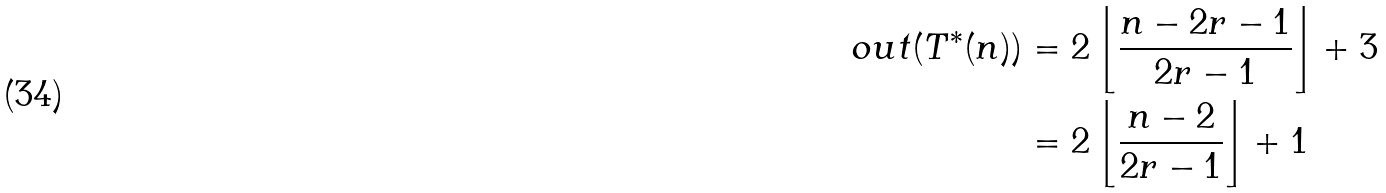Convert formula to latex. <formula><loc_0><loc_0><loc_500><loc_500>o u t ( T ^ { * } ( n ) ) & = 2 \left \lfloor \frac { n - 2 r - 1 } { 2 r - 1 } \right \rfloor + 3 \\ & = 2 \left \lfloor \frac { n - 2 } { 2 r - 1 } \right \rfloor + 1</formula> 